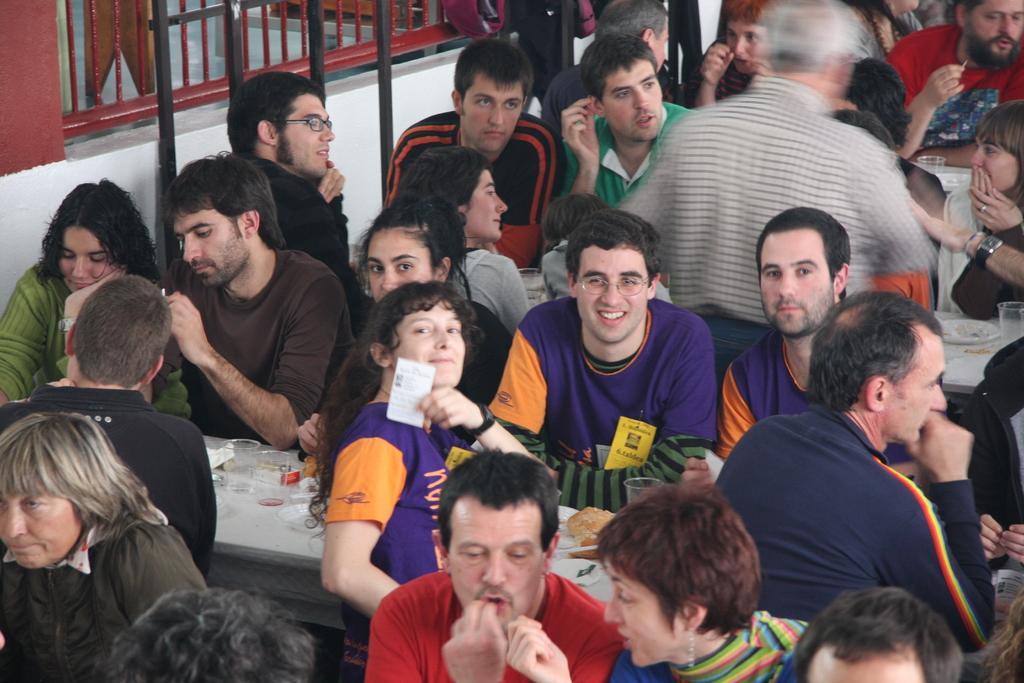Could you give a brief overview of what you see in this image? In this image we can see people sitting and there are tables. We can see glasses, food and plates placed on the tables. In the background there is a railing and a wall. 